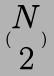Convert formula to latex. <formula><loc_0><loc_0><loc_500><loc_500>( \begin{matrix} N \\ 2 \end{matrix} )</formula> 